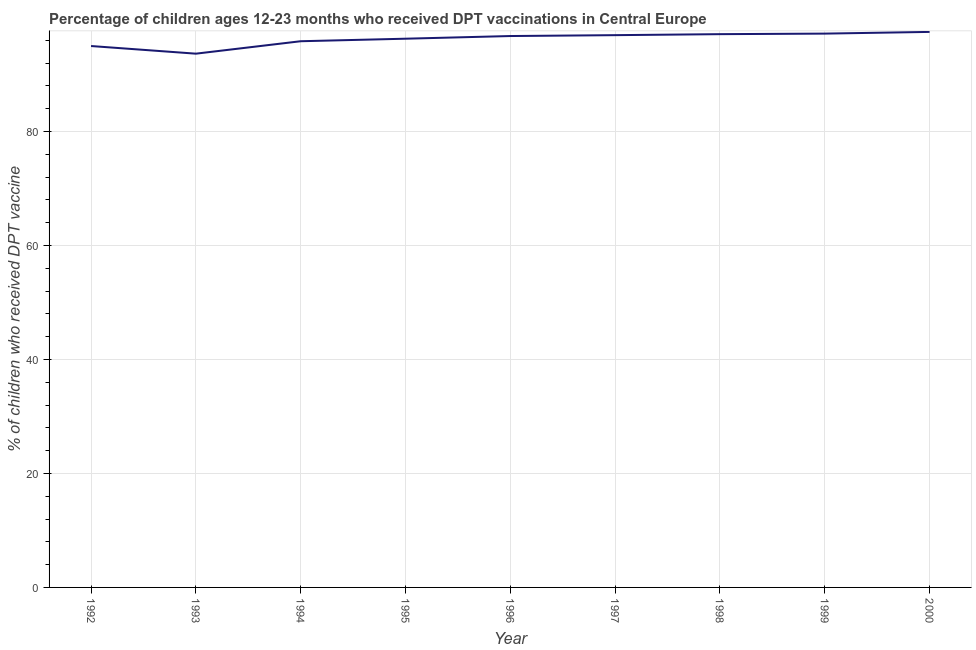What is the percentage of children who received dpt vaccine in 1992?
Keep it short and to the point. 94.99. Across all years, what is the maximum percentage of children who received dpt vaccine?
Offer a terse response. 97.46. Across all years, what is the minimum percentage of children who received dpt vaccine?
Keep it short and to the point. 93.64. What is the sum of the percentage of children who received dpt vaccine?
Ensure brevity in your answer.  866.05. What is the difference between the percentage of children who received dpt vaccine in 1992 and 2000?
Your answer should be very brief. -2.48. What is the average percentage of children who received dpt vaccine per year?
Give a very brief answer. 96.23. What is the median percentage of children who received dpt vaccine?
Your answer should be very brief. 96.74. What is the ratio of the percentage of children who received dpt vaccine in 1993 to that in 1994?
Make the answer very short. 0.98. Is the percentage of children who received dpt vaccine in 1995 less than that in 1996?
Provide a succinct answer. Yes. Is the difference between the percentage of children who received dpt vaccine in 1992 and 1994 greater than the difference between any two years?
Your answer should be very brief. No. What is the difference between the highest and the second highest percentage of children who received dpt vaccine?
Your answer should be compact. 0.3. Is the sum of the percentage of children who received dpt vaccine in 1993 and 1994 greater than the maximum percentage of children who received dpt vaccine across all years?
Offer a terse response. Yes. What is the difference between the highest and the lowest percentage of children who received dpt vaccine?
Your answer should be compact. 3.82. Does the percentage of children who received dpt vaccine monotonically increase over the years?
Keep it short and to the point. No. How many years are there in the graph?
Provide a succinct answer. 9. Does the graph contain any zero values?
Give a very brief answer. No. What is the title of the graph?
Make the answer very short. Percentage of children ages 12-23 months who received DPT vaccinations in Central Europe. What is the label or title of the Y-axis?
Give a very brief answer. % of children who received DPT vaccine. What is the % of children who received DPT vaccine in 1992?
Provide a succinct answer. 94.99. What is the % of children who received DPT vaccine of 1993?
Your response must be concise. 93.64. What is the % of children who received DPT vaccine of 1994?
Give a very brief answer. 95.83. What is the % of children who received DPT vaccine in 1995?
Offer a terse response. 96.27. What is the % of children who received DPT vaccine of 1996?
Provide a short and direct response. 96.74. What is the % of children who received DPT vaccine in 1997?
Offer a very short reply. 96.89. What is the % of children who received DPT vaccine of 1998?
Keep it short and to the point. 97.07. What is the % of children who received DPT vaccine of 1999?
Offer a terse response. 97.16. What is the % of children who received DPT vaccine of 2000?
Your answer should be very brief. 97.46. What is the difference between the % of children who received DPT vaccine in 1992 and 1993?
Offer a very short reply. 1.34. What is the difference between the % of children who received DPT vaccine in 1992 and 1994?
Provide a short and direct response. -0.84. What is the difference between the % of children who received DPT vaccine in 1992 and 1995?
Provide a short and direct response. -1.29. What is the difference between the % of children who received DPT vaccine in 1992 and 1996?
Provide a short and direct response. -1.75. What is the difference between the % of children who received DPT vaccine in 1992 and 1997?
Make the answer very short. -1.91. What is the difference between the % of children who received DPT vaccine in 1992 and 1998?
Your response must be concise. -2.08. What is the difference between the % of children who received DPT vaccine in 1992 and 1999?
Your response must be concise. -2.18. What is the difference between the % of children who received DPT vaccine in 1992 and 2000?
Make the answer very short. -2.48. What is the difference between the % of children who received DPT vaccine in 1993 and 1994?
Make the answer very short. -2.18. What is the difference between the % of children who received DPT vaccine in 1993 and 1995?
Make the answer very short. -2.63. What is the difference between the % of children who received DPT vaccine in 1993 and 1996?
Ensure brevity in your answer.  -3.09. What is the difference between the % of children who received DPT vaccine in 1993 and 1997?
Provide a succinct answer. -3.25. What is the difference between the % of children who received DPT vaccine in 1993 and 1998?
Provide a succinct answer. -3.42. What is the difference between the % of children who received DPT vaccine in 1993 and 1999?
Offer a terse response. -3.52. What is the difference between the % of children who received DPT vaccine in 1993 and 2000?
Your response must be concise. -3.82. What is the difference between the % of children who received DPT vaccine in 1994 and 1995?
Offer a very short reply. -0.44. What is the difference between the % of children who received DPT vaccine in 1994 and 1996?
Your response must be concise. -0.91. What is the difference between the % of children who received DPT vaccine in 1994 and 1997?
Ensure brevity in your answer.  -1.07. What is the difference between the % of children who received DPT vaccine in 1994 and 1998?
Your answer should be very brief. -1.24. What is the difference between the % of children who received DPT vaccine in 1994 and 1999?
Offer a very short reply. -1.34. What is the difference between the % of children who received DPT vaccine in 1994 and 2000?
Give a very brief answer. -1.64. What is the difference between the % of children who received DPT vaccine in 1995 and 1996?
Your response must be concise. -0.47. What is the difference between the % of children who received DPT vaccine in 1995 and 1997?
Provide a short and direct response. -0.62. What is the difference between the % of children who received DPT vaccine in 1995 and 1998?
Your response must be concise. -0.8. What is the difference between the % of children who received DPT vaccine in 1995 and 1999?
Keep it short and to the point. -0.89. What is the difference between the % of children who received DPT vaccine in 1995 and 2000?
Your response must be concise. -1.19. What is the difference between the % of children who received DPT vaccine in 1996 and 1997?
Provide a succinct answer. -0.15. What is the difference between the % of children who received DPT vaccine in 1996 and 1998?
Your answer should be compact. -0.33. What is the difference between the % of children who received DPT vaccine in 1996 and 1999?
Ensure brevity in your answer.  -0.42. What is the difference between the % of children who received DPT vaccine in 1996 and 2000?
Offer a very short reply. -0.72. What is the difference between the % of children who received DPT vaccine in 1997 and 1998?
Your response must be concise. -0.18. What is the difference between the % of children who received DPT vaccine in 1997 and 1999?
Make the answer very short. -0.27. What is the difference between the % of children who received DPT vaccine in 1997 and 2000?
Offer a very short reply. -0.57. What is the difference between the % of children who received DPT vaccine in 1998 and 1999?
Your answer should be very brief. -0.1. What is the difference between the % of children who received DPT vaccine in 1998 and 2000?
Ensure brevity in your answer.  -0.39. What is the difference between the % of children who received DPT vaccine in 1999 and 2000?
Offer a very short reply. -0.3. What is the ratio of the % of children who received DPT vaccine in 1992 to that in 1993?
Your answer should be very brief. 1.01. What is the ratio of the % of children who received DPT vaccine in 1992 to that in 1995?
Your answer should be compact. 0.99. What is the ratio of the % of children who received DPT vaccine in 1992 to that in 1997?
Offer a terse response. 0.98. What is the ratio of the % of children who received DPT vaccine in 1992 to that in 1998?
Your response must be concise. 0.98. What is the ratio of the % of children who received DPT vaccine in 1992 to that in 2000?
Offer a terse response. 0.97. What is the ratio of the % of children who received DPT vaccine in 1993 to that in 1997?
Keep it short and to the point. 0.97. What is the ratio of the % of children who received DPT vaccine in 1994 to that in 1996?
Your answer should be compact. 0.99. What is the ratio of the % of children who received DPT vaccine in 1994 to that in 1999?
Your response must be concise. 0.99. What is the ratio of the % of children who received DPT vaccine in 1994 to that in 2000?
Provide a short and direct response. 0.98. What is the ratio of the % of children who received DPT vaccine in 1995 to that in 1996?
Keep it short and to the point. 0.99. What is the ratio of the % of children who received DPT vaccine in 1995 to that in 1997?
Give a very brief answer. 0.99. What is the ratio of the % of children who received DPT vaccine in 1996 to that in 1999?
Offer a very short reply. 1. What is the ratio of the % of children who received DPT vaccine in 1997 to that in 1998?
Give a very brief answer. 1. What is the ratio of the % of children who received DPT vaccine in 1997 to that in 2000?
Your answer should be very brief. 0.99. What is the ratio of the % of children who received DPT vaccine in 1998 to that in 2000?
Keep it short and to the point. 1. 